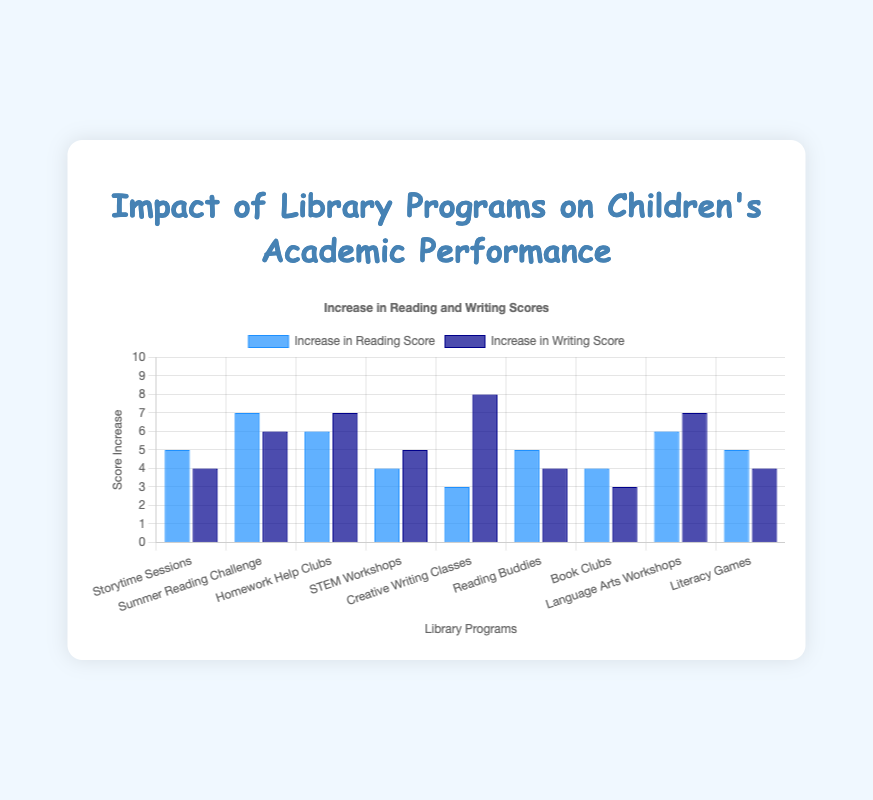What is the program with the highest increase in reading scores? The program with the highest increase in reading scores is identified by comparing the heights of the blue bars. By inspecting the figure, we see that the "Summer Reading Challenge" has the highest reading score increase.
Answer: Summer Reading Challenge Which program shows a greater increase in writing scores compared to reading scores? We look at each program and compare the heights of the corresponding blue (reading) and dark blue (writing) bars. "Creative Writing Classes" shows a greater increase in writing scores than in reading scores.
Answer: Creative Writing Classes What is the total increase in reading scores for all programs combined? To find the total increase in reading scores, sum the heights of all the blue bars. The values are 5, 7, 6, 4, 3, 5, 4, 6, and 5, which sum up to 45.
Answer: 45 Compare the increases in writing scores between "Homework Help Clubs" and "Language Arts Workshops". Which one is higher? By comparing the heights of the dark blue bars of "Homework Help Clubs" and "Language Arts Workshops," we see that both have a writing score increase of 7, so they are equal.
Answer: Equal Which program has the smallest difference between increases in reading and writing scores? To find this, we need to calculate the difference between reading and writing score increases for each program and identify the smallest difference. The differences are: Storytime Sessions (1), Summer Reading Challenge (1), Homework Help Clubs (1), STEM Workshops (1), Creative Writing Classes (5), Reading Buddies (1), Book Clubs (1), Language Arts Workshops (1), Literacy Games (1).
Answer: Multiple programs (Storytime Sessions, Summer Reading Challenge, Homework Help Clubs, STEM Workshops, Reading Buddies, Book Clubs, Language Arts Workshops, Literacy Games) all have the smallest difference of 1 What is the average increase in writing scores across all programs? Summing the heights of all the dark blue bars gives 4 + 6 + 7 + 5 + 8 + 4 + 3 + 7 + 4 = 48. Dividing by the number of programs (9) gives an average of 48 / 9 ≈ 5.33.
Answer: 5.33 Which program has the lowest reading score increase and what is the value? The program with the lowest reading score increase is found by identifying the shortest blue bar, which corresponds to "Creative Writing Classes" with an increase of 3.
Answer: Creative Writing Classes, 3 